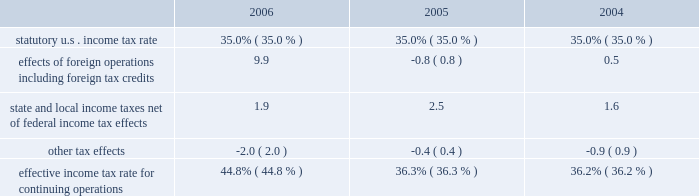For additional information on segment results see page 43 .
Income from equity method investments increased by $ 126 million in 2006 from 2005 and increased by $ 98 million in 2005 from 2004 .
Income from our lpg operations in equatorial guinea increased in both periods due to higher sales volumes as a result of the plant expansions completed in 2005 .
The increase in 2005 also included higher ptc income as a result of higher distillate gross margins .
Cost of revenues increased $ 4.609 billion in 2006 from 2005 and $ 7.106 billion in 2005 from 2004 .
In both periods the increases were primarily in the rm&t segment and resulted from increases in acquisition costs of crude oil , refinery charge and blend stocks and purchased refined products .
The increase in both periods was also impacted by higher manufacturing expenses , primarily the result of higher contract services and labor costs in 2006 and higher purchased energy costs in 2005 .
Purchases related to matching buy/sell transactions decreased $ 6.968 billion in 2006 from 2005 and increased $ 3.314 billion in 2005 from 2004 , mostly in the rm&t segment .
The decrease in 2006 was primarily related to the change in accounting for matching buy/sell transactions discussed above .
The increase in 2005 was primarily due to increased crude oil prices .
Depreciation , depletion and amortization increased $ 215 million in 2006 from 2005 and $ 125 million in 2005 from 2004 .
Rm&t segment depreciation expense increased in both years as a result of the increase in asset value recorded for our acquisition of the 38 percent interest in mpc on june 30 , 2005 .
In addition , the detroit refinery expansion completed in the fourth quarter of 2005 contributed to the rm&t depreciation expense increase in 2006 .
E&p segment depreciation expense for 2006 included a $ 20 million impairment of capitalized costs related to the camden hills field in the gulf of mexico and the associated canyon express pipeline .
Natural gas production from the camden hills field ended in 2006 as a result of increased water production from the well .
Selling , general and administrative expenses increased $ 73 million in 2006 from 2005 and $ 134 million in 2005 from 2004 .
The 2006 increase was primarily because personnel and staffing costs increased throughout the year primarily as a result of variable compensation arrangements and increased business activity .
Partially offsetting these increases were reductions in stock-based compensation expense .
The increase in 2005 was primarily a result of increased stock-based compensation expense , due to the increase in our stock price during that year as well as an increase in equity-based awards , which was partially offset by a decrease in expense as a result of severance and pension plan curtailment charges and start-up costs related to egholdings in 2004 .
Exploration expenses increased $ 148 million in 2006 from 2005 and $ 59 million in 2005 from 2004 .
Exploration expense related to dry wells and other write-offs totaled $ 166 million , $ 111 million and $ 47 million in 2006 , 2005 and 2004 .
Exploration expense in 2006 also included $ 47 million for exiting the cortland and empire leases in nova scotia .
Net interest and other financing costs ( income ) reflected a net $ 37 million of income for 2006 , a favorable change of $ 183 million from the net $ 146 million expense in 2005 .
Net interest and other financing costs decreased $ 16 million in 2005 from 2004 .
The favorable changes in 2006 included increased interest income due to higher interest rates and average cash balances , foreign currency exchange gains , adjustments to interest on tax issues and greater capitalized interest .
The decrease in expense for 2005 was primarily a result of increased interest income on higher average cash balances and greater capitalized interest , partially offset by increased interest on potential tax deficiencies and higher foreign exchange losses .
Included in net interest and other financing costs ( income ) are foreign currency gains of $ 16 million , losses of $ 17 million and gains of $ 9 million for 2006 , 2005 and 2004 .
Minority interest in income of mpc decreased $ 148 million in 2005 from 2004 due to our acquisition of the 38 percent interest in mpc on june 30 , 2005 .
Provision for income taxes increased $ 2.308 billion in 2006 from 2005 and $ 979 million in 2005 from 2004 , primarily due to the $ 4.259 billion and $ 2.691 billion increases in income from continuing operations before income taxes .
The increase in our effective income tax rate in 2006 was primarily a result of the income taxes related to our libyan operations , where the statutory income tax rate is in excess of 90 percent .
The following is an analysis of the effective income tax rates for continuing operations for 2006 , 2005 and 2004 .
See note 11 to the consolidated financial statements for further discussion. .

By what percentage did effects of foreign operations including foreign tax credits increase from 2004 to 2006? 
Computations: ((9.9 - 0.5) / 0.5)
Answer: 18.8. For additional information on segment results see page 43 .
Income from equity method investments increased by $ 126 million in 2006 from 2005 and increased by $ 98 million in 2005 from 2004 .
Income from our lpg operations in equatorial guinea increased in both periods due to higher sales volumes as a result of the plant expansions completed in 2005 .
The increase in 2005 also included higher ptc income as a result of higher distillate gross margins .
Cost of revenues increased $ 4.609 billion in 2006 from 2005 and $ 7.106 billion in 2005 from 2004 .
In both periods the increases were primarily in the rm&t segment and resulted from increases in acquisition costs of crude oil , refinery charge and blend stocks and purchased refined products .
The increase in both periods was also impacted by higher manufacturing expenses , primarily the result of higher contract services and labor costs in 2006 and higher purchased energy costs in 2005 .
Purchases related to matching buy/sell transactions decreased $ 6.968 billion in 2006 from 2005 and increased $ 3.314 billion in 2005 from 2004 , mostly in the rm&t segment .
The decrease in 2006 was primarily related to the change in accounting for matching buy/sell transactions discussed above .
The increase in 2005 was primarily due to increased crude oil prices .
Depreciation , depletion and amortization increased $ 215 million in 2006 from 2005 and $ 125 million in 2005 from 2004 .
Rm&t segment depreciation expense increased in both years as a result of the increase in asset value recorded for our acquisition of the 38 percent interest in mpc on june 30 , 2005 .
In addition , the detroit refinery expansion completed in the fourth quarter of 2005 contributed to the rm&t depreciation expense increase in 2006 .
E&p segment depreciation expense for 2006 included a $ 20 million impairment of capitalized costs related to the camden hills field in the gulf of mexico and the associated canyon express pipeline .
Natural gas production from the camden hills field ended in 2006 as a result of increased water production from the well .
Selling , general and administrative expenses increased $ 73 million in 2006 from 2005 and $ 134 million in 2005 from 2004 .
The 2006 increase was primarily because personnel and staffing costs increased throughout the year primarily as a result of variable compensation arrangements and increased business activity .
Partially offsetting these increases were reductions in stock-based compensation expense .
The increase in 2005 was primarily a result of increased stock-based compensation expense , due to the increase in our stock price during that year as well as an increase in equity-based awards , which was partially offset by a decrease in expense as a result of severance and pension plan curtailment charges and start-up costs related to egholdings in 2004 .
Exploration expenses increased $ 148 million in 2006 from 2005 and $ 59 million in 2005 from 2004 .
Exploration expense related to dry wells and other write-offs totaled $ 166 million , $ 111 million and $ 47 million in 2006 , 2005 and 2004 .
Exploration expense in 2006 also included $ 47 million for exiting the cortland and empire leases in nova scotia .
Net interest and other financing costs ( income ) reflected a net $ 37 million of income for 2006 , a favorable change of $ 183 million from the net $ 146 million expense in 2005 .
Net interest and other financing costs decreased $ 16 million in 2005 from 2004 .
The favorable changes in 2006 included increased interest income due to higher interest rates and average cash balances , foreign currency exchange gains , adjustments to interest on tax issues and greater capitalized interest .
The decrease in expense for 2005 was primarily a result of increased interest income on higher average cash balances and greater capitalized interest , partially offset by increased interest on potential tax deficiencies and higher foreign exchange losses .
Included in net interest and other financing costs ( income ) are foreign currency gains of $ 16 million , losses of $ 17 million and gains of $ 9 million for 2006 , 2005 and 2004 .
Minority interest in income of mpc decreased $ 148 million in 2005 from 2004 due to our acquisition of the 38 percent interest in mpc on june 30 , 2005 .
Provision for income taxes increased $ 2.308 billion in 2006 from 2005 and $ 979 million in 2005 from 2004 , primarily due to the $ 4.259 billion and $ 2.691 billion increases in income from continuing operations before income taxes .
The increase in our effective income tax rate in 2006 was primarily a result of the income taxes related to our libyan operations , where the statutory income tax rate is in excess of 90 percent .
The following is an analysis of the effective income tax rates for continuing operations for 2006 , 2005 and 2004 .
See note 11 to the consolidated financial statements for further discussion. .

What was the average percent of foreign operations including foreign tax credits for the three year period? 
Computations: table_average(effects of foreign operations including foreign tax credits, none)
Answer: 3.2. 